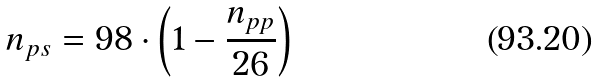<formula> <loc_0><loc_0><loc_500><loc_500>n _ { p s } = 9 8 \cdot \left ( 1 - \frac { n _ { p p } } { 2 6 } \right )</formula> 